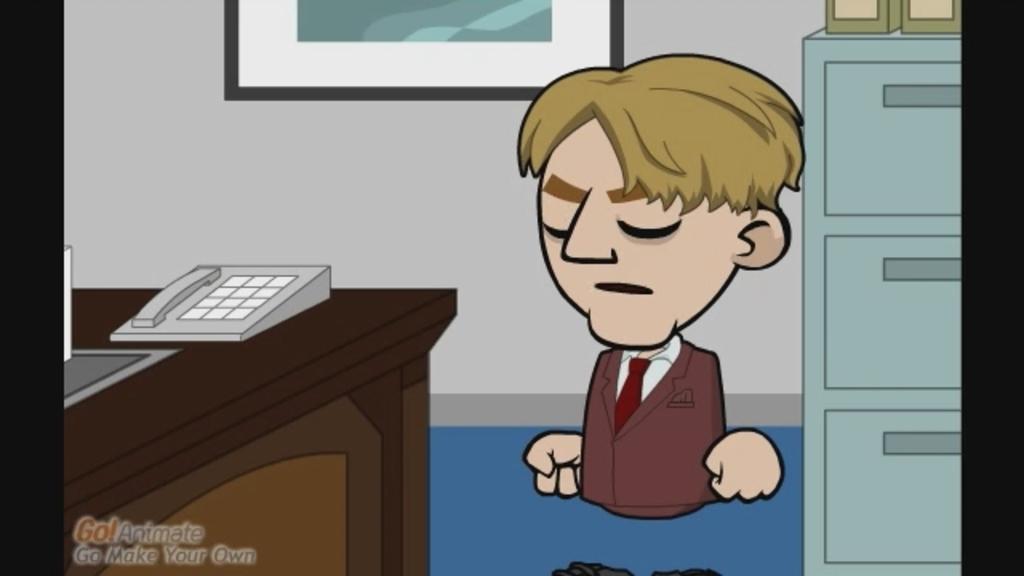How would you summarize this image in a sentence or two? This image is an animated image. In the background there is a wall with a picture frame on it. On the right side of the image there is a cupboard and there are two objects on the cupboard. There is a man. On the left side of the image there is a table with a telephone and an object on it. 